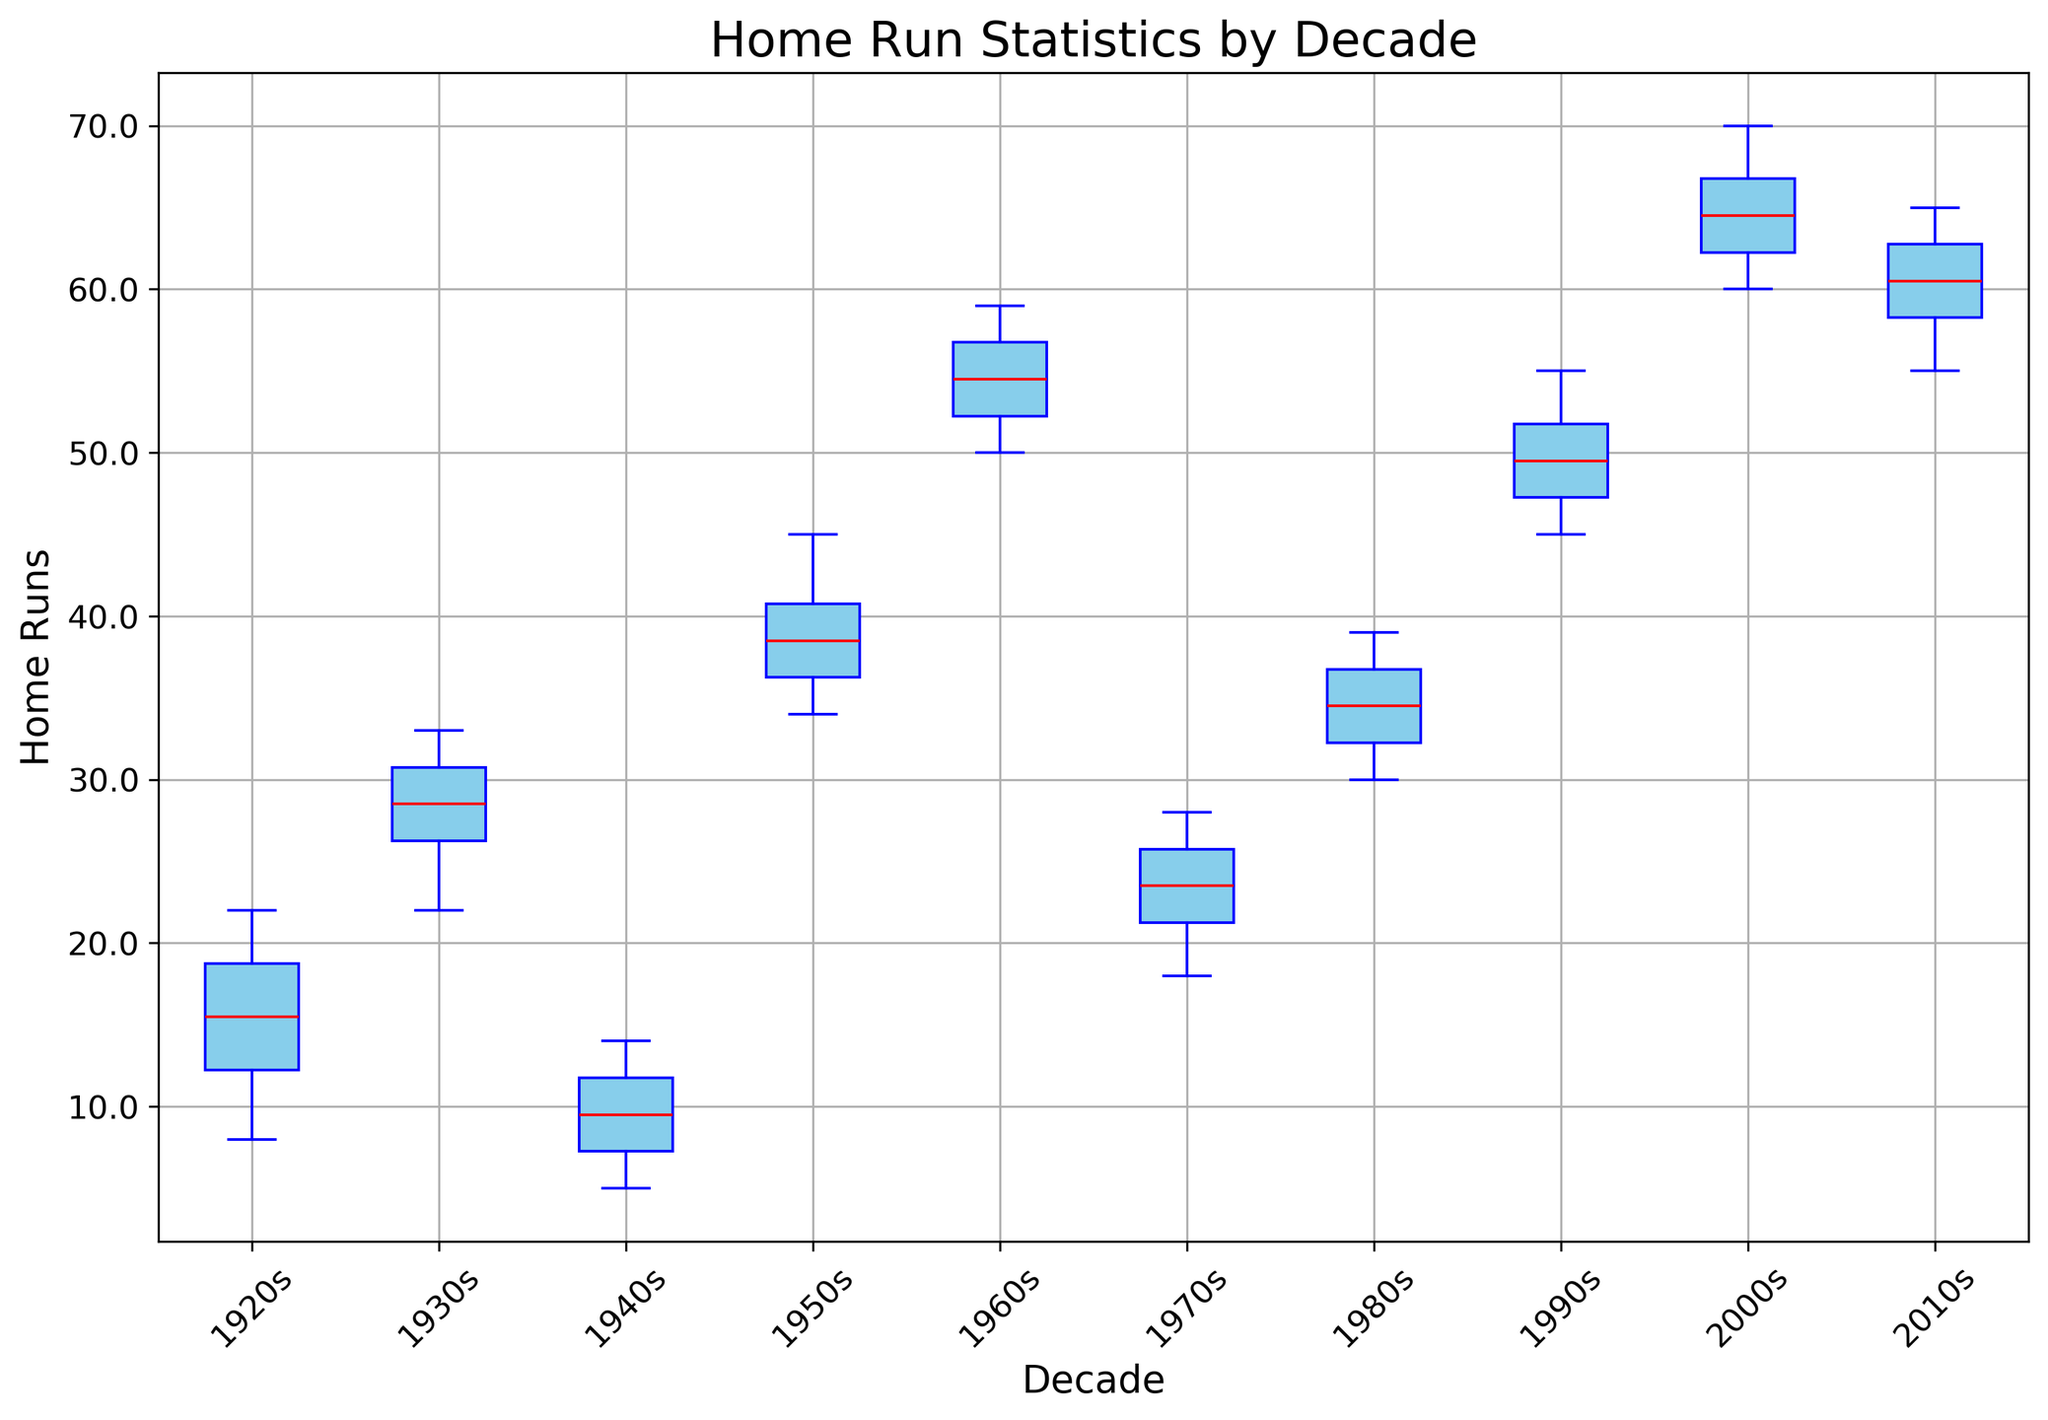Which decade has the highest median number of home runs? To find the highest median number of home runs, look at the red median lines across the box plots and identify the highest one. The 2000s have the highest median line.
Answer: 2000s How do the interquartile ranges (IQR) for the 1960s and 1980s compare? The IQR is determined by the length of the box in the box plot, representing the range between the first quartile (Q1) and the third quartile (Q3). The box for the 1960s is taller than the box for the 1980s, indicating a larger IQR.
Answer: 1960s has a larger IQR Which decade shows the greatest variability in home run statistics? Variability is indicated by the total range of the box plot, including whiskers. The box plot for the 2000s has taller whiskers and more spread-out fliers, suggesting the greatest variability.
Answer: 2000s What is the median value of home runs in the 1970s, and how does it compare to the 1990s? Look at the red median lines for both the 1970s and 1990s. The median for the 1970s is lower than that for the 1990s. Specifically, the median for the 1970s is approximately 23, while for the 1990s it is 50.
Answer: 23 for 1970s, 50 for 1990s Which decade has the lowest maximum value of home runs? The maximum values are shown by the top whiskers of each box plot. The 1940s have the lowest maximum value since its top whisker is the shortest.
Answer: 1940s Are there any outliers in the dataset? If so, which decades do they appear in? Outliers are shown as green dots outside the whiskers of the box plots. The 2000s and 2010s have green dots indicating outliers.
Answer: 2000s, 2010s How does the spread of data for the 1950s compare to that of the 1980s? Compare the height of the boxes and the whiskers. Both decades have similar heights for their boxes and whiskers, indicating similar spreads.
Answer: Similar spread What is the range of the interquartile range (IQR) values across all decades? The range of the IQR values is determined by the largest and smallest boxes. The 1960s have the tallest box, and the 1920s have one of the shortest. Estimating, the 1960s IQR is about 9 (59-50), and the 1920s IQR is about 6 (18-12). The range of IQRs is the difference between the tallest and shortest boxes.
Answer: Range of IQRs is about 9-6 = 3 Which decade has the least median home runs, and what is that value? Identify the lowest red median line. The 1940s have the least median value, which is approximately 9.
Answer: 1940s, 9 If we consider the most common value (mode) within each decade, which decade likely has the highest frequency of a single number? For mode, we'd look for the value that appears most frequently in the middle of the box (often near the median). The 2000s show a cluster around the median 60-65, suggesting closely-packed values.
Answer: 2000s 